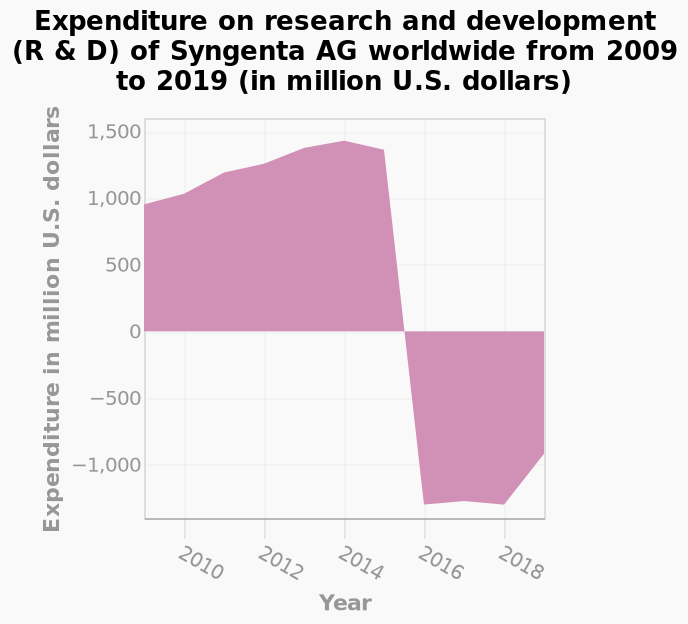<image>
please describe the details of the chart Expenditure on research and development (R & D) of Syngenta AG worldwide from 2009 to 2019 (in million U.S. dollars) is a area plot. There is a categorical scale starting at −1,000 and ending at 1,500 on the y-axis, labeled Expenditure in million U.S. dollars. On the x-axis, Year is shown with a linear scale with a minimum of 2010 and a maximum of 2018. please summary the statistics and relations of the chart There is a steady increase from 2008 to end of 2015. Then there is a quick decline from 2015 to 2019. Did the spending on research and development decrease after 2016?  The spending on research and development stopped completely after 2016, so there was no decrease or increase. Was any research and development undertaken after 2016? No, there was no research and development undertaken after 2016. 